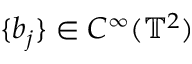<formula> <loc_0><loc_0><loc_500><loc_500>\{ b _ { j } \} \in C ^ { \infty } ( \mathbb { T } ^ { 2 } )</formula> 